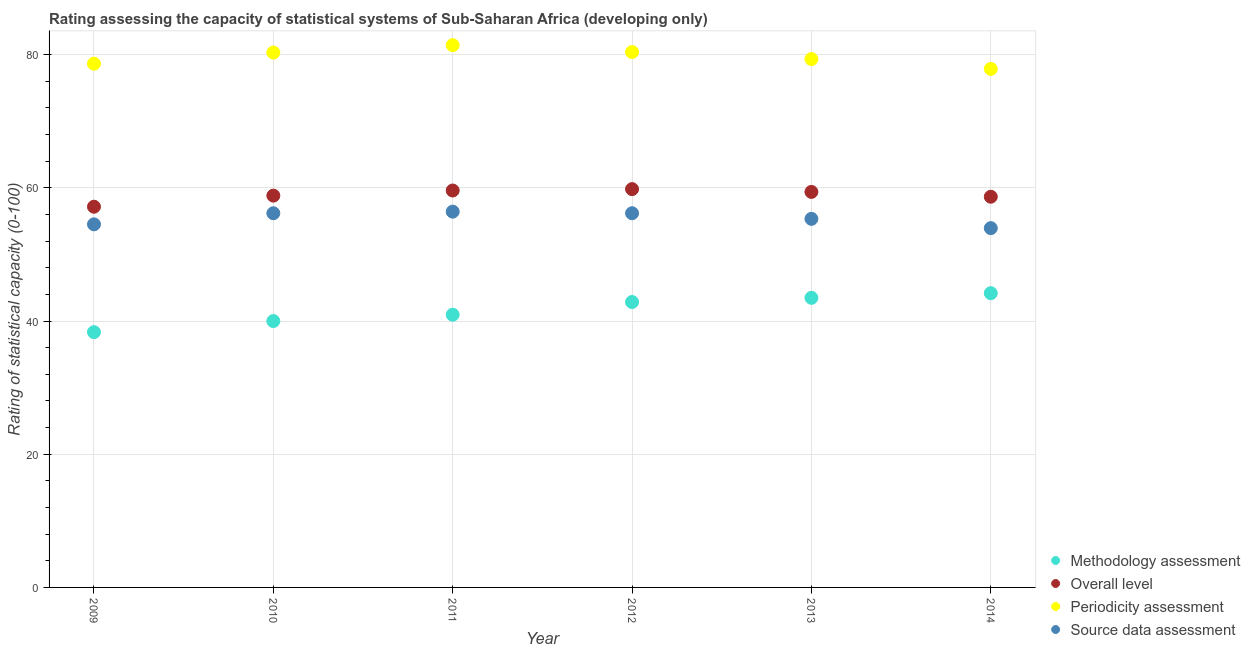How many different coloured dotlines are there?
Offer a terse response. 4. What is the periodicity assessment rating in 2013?
Give a very brief answer. 79.34. Across all years, what is the maximum methodology assessment rating?
Offer a terse response. 44.19. Across all years, what is the minimum periodicity assessment rating?
Provide a succinct answer. 77.87. In which year was the periodicity assessment rating maximum?
Give a very brief answer. 2011. What is the total source data assessment rating in the graph?
Your response must be concise. 332.64. What is the difference between the methodology assessment rating in 2012 and that in 2013?
Keep it short and to the point. -0.63. What is the difference between the source data assessment rating in 2012 and the overall level rating in 2009?
Your response must be concise. -0.98. What is the average methodology assessment rating per year?
Your answer should be very brief. 41.64. In the year 2014, what is the difference between the methodology assessment rating and overall level rating?
Keep it short and to the point. -14.48. What is the ratio of the overall level rating in 2009 to that in 2012?
Provide a succinct answer. 0.96. Is the periodicity assessment rating in 2011 less than that in 2014?
Your answer should be compact. No. Is the difference between the periodicity assessment rating in 2009 and 2010 greater than the difference between the source data assessment rating in 2009 and 2010?
Provide a succinct answer. No. What is the difference between the highest and the second highest periodicity assessment rating?
Offer a very short reply. 1.03. What is the difference between the highest and the lowest overall level rating?
Provide a succinct answer. 2.65. Is the sum of the methodology assessment rating in 2010 and 2014 greater than the maximum source data assessment rating across all years?
Your response must be concise. Yes. Is it the case that in every year, the sum of the periodicity assessment rating and source data assessment rating is greater than the sum of overall level rating and methodology assessment rating?
Provide a succinct answer. Yes. Does the source data assessment rating monotonically increase over the years?
Provide a short and direct response. No. Is the overall level rating strictly greater than the methodology assessment rating over the years?
Keep it short and to the point. Yes. How many dotlines are there?
Provide a succinct answer. 4. How many years are there in the graph?
Offer a very short reply. 6. Are the values on the major ticks of Y-axis written in scientific E-notation?
Keep it short and to the point. No. Does the graph contain grids?
Your answer should be compact. Yes. How many legend labels are there?
Offer a very short reply. 4. How are the legend labels stacked?
Offer a very short reply. Vertical. What is the title of the graph?
Keep it short and to the point. Rating assessing the capacity of statistical systems of Sub-Saharan Africa (developing only). Does "Salary of employees" appear as one of the legend labels in the graph?
Provide a short and direct response. No. What is the label or title of the X-axis?
Keep it short and to the point. Year. What is the label or title of the Y-axis?
Make the answer very short. Rating of statistical capacity (0-100). What is the Rating of statistical capacity (0-100) of Methodology assessment in 2009?
Offer a very short reply. 38.33. What is the Rating of statistical capacity (0-100) in Overall level in 2009?
Provide a succinct answer. 57.17. What is the Rating of statistical capacity (0-100) in Periodicity assessment in 2009?
Keep it short and to the point. 78.65. What is the Rating of statistical capacity (0-100) in Source data assessment in 2009?
Ensure brevity in your answer.  54.52. What is the Rating of statistical capacity (0-100) in Methodology assessment in 2010?
Keep it short and to the point. 40. What is the Rating of statistical capacity (0-100) of Overall level in 2010?
Make the answer very short. 58.84. What is the Rating of statistical capacity (0-100) of Periodicity assessment in 2010?
Ensure brevity in your answer.  80.32. What is the Rating of statistical capacity (0-100) of Source data assessment in 2010?
Offer a terse response. 56.19. What is the Rating of statistical capacity (0-100) of Methodology assessment in 2011?
Provide a short and direct response. 40.95. What is the Rating of statistical capacity (0-100) in Overall level in 2011?
Give a very brief answer. 59.6. What is the Rating of statistical capacity (0-100) of Periodicity assessment in 2011?
Keep it short and to the point. 81.43. What is the Rating of statistical capacity (0-100) of Source data assessment in 2011?
Provide a short and direct response. 56.43. What is the Rating of statistical capacity (0-100) of Methodology assessment in 2012?
Your answer should be very brief. 42.86. What is the Rating of statistical capacity (0-100) of Overall level in 2012?
Give a very brief answer. 59.81. What is the Rating of statistical capacity (0-100) in Periodicity assessment in 2012?
Your answer should be compact. 80.4. What is the Rating of statistical capacity (0-100) of Source data assessment in 2012?
Give a very brief answer. 56.19. What is the Rating of statistical capacity (0-100) in Methodology assessment in 2013?
Provide a short and direct response. 43.49. What is the Rating of statistical capacity (0-100) in Overall level in 2013?
Give a very brief answer. 59.39. What is the Rating of statistical capacity (0-100) of Periodicity assessment in 2013?
Offer a very short reply. 79.34. What is the Rating of statistical capacity (0-100) of Source data assessment in 2013?
Your response must be concise. 55.35. What is the Rating of statistical capacity (0-100) in Methodology assessment in 2014?
Provide a succinct answer. 44.19. What is the Rating of statistical capacity (0-100) in Overall level in 2014?
Your response must be concise. 58.67. What is the Rating of statistical capacity (0-100) in Periodicity assessment in 2014?
Offer a very short reply. 77.87. What is the Rating of statistical capacity (0-100) in Source data assessment in 2014?
Provide a short and direct response. 53.95. Across all years, what is the maximum Rating of statistical capacity (0-100) of Methodology assessment?
Your answer should be very brief. 44.19. Across all years, what is the maximum Rating of statistical capacity (0-100) of Overall level?
Your answer should be very brief. 59.81. Across all years, what is the maximum Rating of statistical capacity (0-100) of Periodicity assessment?
Your answer should be very brief. 81.43. Across all years, what is the maximum Rating of statistical capacity (0-100) of Source data assessment?
Keep it short and to the point. 56.43. Across all years, what is the minimum Rating of statistical capacity (0-100) of Methodology assessment?
Provide a succinct answer. 38.33. Across all years, what is the minimum Rating of statistical capacity (0-100) in Overall level?
Ensure brevity in your answer.  57.17. Across all years, what is the minimum Rating of statistical capacity (0-100) of Periodicity assessment?
Make the answer very short. 77.87. Across all years, what is the minimum Rating of statistical capacity (0-100) in Source data assessment?
Give a very brief answer. 53.95. What is the total Rating of statistical capacity (0-100) in Methodology assessment in the graph?
Give a very brief answer. 249.82. What is the total Rating of statistical capacity (0-100) in Overall level in the graph?
Your answer should be very brief. 353.49. What is the total Rating of statistical capacity (0-100) in Periodicity assessment in the graph?
Your answer should be compact. 478. What is the total Rating of statistical capacity (0-100) of Source data assessment in the graph?
Your response must be concise. 332.64. What is the difference between the Rating of statistical capacity (0-100) of Methodology assessment in 2009 and that in 2010?
Provide a short and direct response. -1.67. What is the difference between the Rating of statistical capacity (0-100) in Overall level in 2009 and that in 2010?
Provide a succinct answer. -1.67. What is the difference between the Rating of statistical capacity (0-100) in Periodicity assessment in 2009 and that in 2010?
Ensure brevity in your answer.  -1.67. What is the difference between the Rating of statistical capacity (0-100) of Source data assessment in 2009 and that in 2010?
Your response must be concise. -1.67. What is the difference between the Rating of statistical capacity (0-100) of Methodology assessment in 2009 and that in 2011?
Your answer should be compact. -2.62. What is the difference between the Rating of statistical capacity (0-100) of Overall level in 2009 and that in 2011?
Keep it short and to the point. -2.43. What is the difference between the Rating of statistical capacity (0-100) in Periodicity assessment in 2009 and that in 2011?
Your response must be concise. -2.78. What is the difference between the Rating of statistical capacity (0-100) of Source data assessment in 2009 and that in 2011?
Give a very brief answer. -1.9. What is the difference between the Rating of statistical capacity (0-100) of Methodology assessment in 2009 and that in 2012?
Your response must be concise. -4.52. What is the difference between the Rating of statistical capacity (0-100) in Overall level in 2009 and that in 2012?
Provide a short and direct response. -2.65. What is the difference between the Rating of statistical capacity (0-100) of Periodicity assessment in 2009 and that in 2012?
Make the answer very short. -1.75. What is the difference between the Rating of statistical capacity (0-100) of Source data assessment in 2009 and that in 2012?
Provide a succinct answer. -1.67. What is the difference between the Rating of statistical capacity (0-100) of Methodology assessment in 2009 and that in 2013?
Your response must be concise. -5.16. What is the difference between the Rating of statistical capacity (0-100) in Overall level in 2009 and that in 2013?
Keep it short and to the point. -2.22. What is the difference between the Rating of statistical capacity (0-100) in Periodicity assessment in 2009 and that in 2013?
Offer a terse response. -0.69. What is the difference between the Rating of statistical capacity (0-100) in Source data assessment in 2009 and that in 2013?
Offer a terse response. -0.82. What is the difference between the Rating of statistical capacity (0-100) in Methodology assessment in 2009 and that in 2014?
Offer a terse response. -5.85. What is the difference between the Rating of statistical capacity (0-100) in Overall level in 2009 and that in 2014?
Provide a succinct answer. -1.5. What is the difference between the Rating of statistical capacity (0-100) in Periodicity assessment in 2009 and that in 2014?
Provide a short and direct response. 0.78. What is the difference between the Rating of statistical capacity (0-100) in Source data assessment in 2009 and that in 2014?
Give a very brief answer. 0.57. What is the difference between the Rating of statistical capacity (0-100) of Methodology assessment in 2010 and that in 2011?
Offer a terse response. -0.95. What is the difference between the Rating of statistical capacity (0-100) of Overall level in 2010 and that in 2011?
Make the answer very short. -0.77. What is the difference between the Rating of statistical capacity (0-100) in Periodicity assessment in 2010 and that in 2011?
Offer a very short reply. -1.11. What is the difference between the Rating of statistical capacity (0-100) in Source data assessment in 2010 and that in 2011?
Make the answer very short. -0.24. What is the difference between the Rating of statistical capacity (0-100) in Methodology assessment in 2010 and that in 2012?
Ensure brevity in your answer.  -2.86. What is the difference between the Rating of statistical capacity (0-100) of Overall level in 2010 and that in 2012?
Your answer should be very brief. -0.98. What is the difference between the Rating of statistical capacity (0-100) of Periodicity assessment in 2010 and that in 2012?
Make the answer very short. -0.08. What is the difference between the Rating of statistical capacity (0-100) of Methodology assessment in 2010 and that in 2013?
Offer a terse response. -3.49. What is the difference between the Rating of statistical capacity (0-100) of Overall level in 2010 and that in 2013?
Offer a terse response. -0.56. What is the difference between the Rating of statistical capacity (0-100) in Periodicity assessment in 2010 and that in 2013?
Offer a very short reply. 0.98. What is the difference between the Rating of statistical capacity (0-100) of Source data assessment in 2010 and that in 2013?
Keep it short and to the point. 0.84. What is the difference between the Rating of statistical capacity (0-100) of Methodology assessment in 2010 and that in 2014?
Give a very brief answer. -4.19. What is the difference between the Rating of statistical capacity (0-100) of Overall level in 2010 and that in 2014?
Offer a very short reply. 0.17. What is the difference between the Rating of statistical capacity (0-100) of Periodicity assessment in 2010 and that in 2014?
Make the answer very short. 2.45. What is the difference between the Rating of statistical capacity (0-100) of Source data assessment in 2010 and that in 2014?
Offer a terse response. 2.24. What is the difference between the Rating of statistical capacity (0-100) in Methodology assessment in 2011 and that in 2012?
Your answer should be very brief. -1.9. What is the difference between the Rating of statistical capacity (0-100) in Overall level in 2011 and that in 2012?
Offer a terse response. -0.21. What is the difference between the Rating of statistical capacity (0-100) of Periodicity assessment in 2011 and that in 2012?
Ensure brevity in your answer.  1.03. What is the difference between the Rating of statistical capacity (0-100) of Source data assessment in 2011 and that in 2012?
Offer a terse response. 0.24. What is the difference between the Rating of statistical capacity (0-100) in Methodology assessment in 2011 and that in 2013?
Your answer should be compact. -2.54. What is the difference between the Rating of statistical capacity (0-100) of Overall level in 2011 and that in 2013?
Offer a terse response. 0.21. What is the difference between the Rating of statistical capacity (0-100) in Periodicity assessment in 2011 and that in 2013?
Offer a very short reply. 2.09. What is the difference between the Rating of statistical capacity (0-100) in Source data assessment in 2011 and that in 2013?
Provide a short and direct response. 1.08. What is the difference between the Rating of statistical capacity (0-100) of Methodology assessment in 2011 and that in 2014?
Offer a terse response. -3.23. What is the difference between the Rating of statistical capacity (0-100) of Overall level in 2011 and that in 2014?
Your response must be concise. 0.93. What is the difference between the Rating of statistical capacity (0-100) of Periodicity assessment in 2011 and that in 2014?
Keep it short and to the point. 3.56. What is the difference between the Rating of statistical capacity (0-100) in Source data assessment in 2011 and that in 2014?
Keep it short and to the point. 2.48. What is the difference between the Rating of statistical capacity (0-100) in Methodology assessment in 2012 and that in 2013?
Your response must be concise. -0.63. What is the difference between the Rating of statistical capacity (0-100) in Overall level in 2012 and that in 2013?
Your answer should be very brief. 0.42. What is the difference between the Rating of statistical capacity (0-100) in Periodicity assessment in 2012 and that in 2013?
Offer a very short reply. 1.06. What is the difference between the Rating of statistical capacity (0-100) of Source data assessment in 2012 and that in 2013?
Offer a terse response. 0.84. What is the difference between the Rating of statistical capacity (0-100) in Methodology assessment in 2012 and that in 2014?
Ensure brevity in your answer.  -1.33. What is the difference between the Rating of statistical capacity (0-100) of Overall level in 2012 and that in 2014?
Offer a very short reply. 1.15. What is the difference between the Rating of statistical capacity (0-100) in Periodicity assessment in 2012 and that in 2014?
Provide a succinct answer. 2.53. What is the difference between the Rating of statistical capacity (0-100) of Source data assessment in 2012 and that in 2014?
Provide a short and direct response. 2.24. What is the difference between the Rating of statistical capacity (0-100) in Methodology assessment in 2013 and that in 2014?
Your response must be concise. -0.7. What is the difference between the Rating of statistical capacity (0-100) of Overall level in 2013 and that in 2014?
Ensure brevity in your answer.  0.72. What is the difference between the Rating of statistical capacity (0-100) of Periodicity assessment in 2013 and that in 2014?
Make the answer very short. 1.47. What is the difference between the Rating of statistical capacity (0-100) of Source data assessment in 2013 and that in 2014?
Offer a very short reply. 1.4. What is the difference between the Rating of statistical capacity (0-100) of Methodology assessment in 2009 and the Rating of statistical capacity (0-100) of Overall level in 2010?
Ensure brevity in your answer.  -20.5. What is the difference between the Rating of statistical capacity (0-100) of Methodology assessment in 2009 and the Rating of statistical capacity (0-100) of Periodicity assessment in 2010?
Offer a very short reply. -41.98. What is the difference between the Rating of statistical capacity (0-100) of Methodology assessment in 2009 and the Rating of statistical capacity (0-100) of Source data assessment in 2010?
Provide a short and direct response. -17.86. What is the difference between the Rating of statistical capacity (0-100) in Overall level in 2009 and the Rating of statistical capacity (0-100) in Periodicity assessment in 2010?
Offer a terse response. -23.15. What is the difference between the Rating of statistical capacity (0-100) in Overall level in 2009 and the Rating of statistical capacity (0-100) in Source data assessment in 2010?
Offer a terse response. 0.98. What is the difference between the Rating of statistical capacity (0-100) of Periodicity assessment in 2009 and the Rating of statistical capacity (0-100) of Source data assessment in 2010?
Your answer should be compact. 22.46. What is the difference between the Rating of statistical capacity (0-100) in Methodology assessment in 2009 and the Rating of statistical capacity (0-100) in Overall level in 2011?
Your response must be concise. -21.27. What is the difference between the Rating of statistical capacity (0-100) of Methodology assessment in 2009 and the Rating of statistical capacity (0-100) of Periodicity assessment in 2011?
Keep it short and to the point. -43.1. What is the difference between the Rating of statistical capacity (0-100) in Methodology assessment in 2009 and the Rating of statistical capacity (0-100) in Source data assessment in 2011?
Ensure brevity in your answer.  -18.1. What is the difference between the Rating of statistical capacity (0-100) in Overall level in 2009 and the Rating of statistical capacity (0-100) in Periodicity assessment in 2011?
Offer a very short reply. -24.26. What is the difference between the Rating of statistical capacity (0-100) of Overall level in 2009 and the Rating of statistical capacity (0-100) of Source data assessment in 2011?
Provide a succinct answer. 0.74. What is the difference between the Rating of statistical capacity (0-100) in Periodicity assessment in 2009 and the Rating of statistical capacity (0-100) in Source data assessment in 2011?
Provide a short and direct response. 22.22. What is the difference between the Rating of statistical capacity (0-100) of Methodology assessment in 2009 and the Rating of statistical capacity (0-100) of Overall level in 2012?
Ensure brevity in your answer.  -21.48. What is the difference between the Rating of statistical capacity (0-100) in Methodology assessment in 2009 and the Rating of statistical capacity (0-100) in Periodicity assessment in 2012?
Your answer should be very brief. -42.06. What is the difference between the Rating of statistical capacity (0-100) of Methodology assessment in 2009 and the Rating of statistical capacity (0-100) of Source data assessment in 2012?
Offer a terse response. -17.86. What is the difference between the Rating of statistical capacity (0-100) in Overall level in 2009 and the Rating of statistical capacity (0-100) in Periodicity assessment in 2012?
Provide a short and direct response. -23.23. What is the difference between the Rating of statistical capacity (0-100) of Overall level in 2009 and the Rating of statistical capacity (0-100) of Source data assessment in 2012?
Offer a terse response. 0.98. What is the difference between the Rating of statistical capacity (0-100) of Periodicity assessment in 2009 and the Rating of statistical capacity (0-100) of Source data assessment in 2012?
Keep it short and to the point. 22.46. What is the difference between the Rating of statistical capacity (0-100) in Methodology assessment in 2009 and the Rating of statistical capacity (0-100) in Overall level in 2013?
Your answer should be very brief. -21.06. What is the difference between the Rating of statistical capacity (0-100) in Methodology assessment in 2009 and the Rating of statistical capacity (0-100) in Periodicity assessment in 2013?
Provide a succinct answer. -41.01. What is the difference between the Rating of statistical capacity (0-100) of Methodology assessment in 2009 and the Rating of statistical capacity (0-100) of Source data assessment in 2013?
Offer a terse response. -17.02. What is the difference between the Rating of statistical capacity (0-100) in Overall level in 2009 and the Rating of statistical capacity (0-100) in Periodicity assessment in 2013?
Your answer should be very brief. -22.17. What is the difference between the Rating of statistical capacity (0-100) in Overall level in 2009 and the Rating of statistical capacity (0-100) in Source data assessment in 2013?
Your answer should be compact. 1.82. What is the difference between the Rating of statistical capacity (0-100) in Periodicity assessment in 2009 and the Rating of statistical capacity (0-100) in Source data assessment in 2013?
Provide a short and direct response. 23.3. What is the difference between the Rating of statistical capacity (0-100) of Methodology assessment in 2009 and the Rating of statistical capacity (0-100) of Overall level in 2014?
Provide a succinct answer. -20.34. What is the difference between the Rating of statistical capacity (0-100) in Methodology assessment in 2009 and the Rating of statistical capacity (0-100) in Periodicity assessment in 2014?
Your response must be concise. -39.53. What is the difference between the Rating of statistical capacity (0-100) of Methodology assessment in 2009 and the Rating of statistical capacity (0-100) of Source data assessment in 2014?
Offer a terse response. -15.62. What is the difference between the Rating of statistical capacity (0-100) in Overall level in 2009 and the Rating of statistical capacity (0-100) in Periodicity assessment in 2014?
Your answer should be very brief. -20.7. What is the difference between the Rating of statistical capacity (0-100) of Overall level in 2009 and the Rating of statistical capacity (0-100) of Source data assessment in 2014?
Make the answer very short. 3.22. What is the difference between the Rating of statistical capacity (0-100) in Periodicity assessment in 2009 and the Rating of statistical capacity (0-100) in Source data assessment in 2014?
Your answer should be very brief. 24.7. What is the difference between the Rating of statistical capacity (0-100) in Methodology assessment in 2010 and the Rating of statistical capacity (0-100) in Overall level in 2011?
Give a very brief answer. -19.6. What is the difference between the Rating of statistical capacity (0-100) of Methodology assessment in 2010 and the Rating of statistical capacity (0-100) of Periodicity assessment in 2011?
Give a very brief answer. -41.43. What is the difference between the Rating of statistical capacity (0-100) in Methodology assessment in 2010 and the Rating of statistical capacity (0-100) in Source data assessment in 2011?
Keep it short and to the point. -16.43. What is the difference between the Rating of statistical capacity (0-100) of Overall level in 2010 and the Rating of statistical capacity (0-100) of Periodicity assessment in 2011?
Offer a terse response. -22.59. What is the difference between the Rating of statistical capacity (0-100) in Overall level in 2010 and the Rating of statistical capacity (0-100) in Source data assessment in 2011?
Your answer should be very brief. 2.41. What is the difference between the Rating of statistical capacity (0-100) of Periodicity assessment in 2010 and the Rating of statistical capacity (0-100) of Source data assessment in 2011?
Provide a succinct answer. 23.89. What is the difference between the Rating of statistical capacity (0-100) in Methodology assessment in 2010 and the Rating of statistical capacity (0-100) in Overall level in 2012?
Provide a succinct answer. -19.81. What is the difference between the Rating of statistical capacity (0-100) in Methodology assessment in 2010 and the Rating of statistical capacity (0-100) in Periodicity assessment in 2012?
Offer a terse response. -40.4. What is the difference between the Rating of statistical capacity (0-100) of Methodology assessment in 2010 and the Rating of statistical capacity (0-100) of Source data assessment in 2012?
Offer a terse response. -16.19. What is the difference between the Rating of statistical capacity (0-100) of Overall level in 2010 and the Rating of statistical capacity (0-100) of Periodicity assessment in 2012?
Provide a succinct answer. -21.56. What is the difference between the Rating of statistical capacity (0-100) in Overall level in 2010 and the Rating of statistical capacity (0-100) in Source data assessment in 2012?
Your answer should be very brief. 2.65. What is the difference between the Rating of statistical capacity (0-100) of Periodicity assessment in 2010 and the Rating of statistical capacity (0-100) of Source data assessment in 2012?
Offer a very short reply. 24.13. What is the difference between the Rating of statistical capacity (0-100) in Methodology assessment in 2010 and the Rating of statistical capacity (0-100) in Overall level in 2013?
Make the answer very short. -19.39. What is the difference between the Rating of statistical capacity (0-100) in Methodology assessment in 2010 and the Rating of statistical capacity (0-100) in Periodicity assessment in 2013?
Your answer should be compact. -39.34. What is the difference between the Rating of statistical capacity (0-100) in Methodology assessment in 2010 and the Rating of statistical capacity (0-100) in Source data assessment in 2013?
Make the answer very short. -15.35. What is the difference between the Rating of statistical capacity (0-100) in Overall level in 2010 and the Rating of statistical capacity (0-100) in Periodicity assessment in 2013?
Provide a succinct answer. -20.51. What is the difference between the Rating of statistical capacity (0-100) of Overall level in 2010 and the Rating of statistical capacity (0-100) of Source data assessment in 2013?
Your answer should be compact. 3.49. What is the difference between the Rating of statistical capacity (0-100) of Periodicity assessment in 2010 and the Rating of statistical capacity (0-100) of Source data assessment in 2013?
Provide a short and direct response. 24.97. What is the difference between the Rating of statistical capacity (0-100) in Methodology assessment in 2010 and the Rating of statistical capacity (0-100) in Overall level in 2014?
Your answer should be very brief. -18.67. What is the difference between the Rating of statistical capacity (0-100) in Methodology assessment in 2010 and the Rating of statistical capacity (0-100) in Periodicity assessment in 2014?
Make the answer very short. -37.87. What is the difference between the Rating of statistical capacity (0-100) in Methodology assessment in 2010 and the Rating of statistical capacity (0-100) in Source data assessment in 2014?
Keep it short and to the point. -13.95. What is the difference between the Rating of statistical capacity (0-100) in Overall level in 2010 and the Rating of statistical capacity (0-100) in Periodicity assessment in 2014?
Offer a very short reply. -19.03. What is the difference between the Rating of statistical capacity (0-100) in Overall level in 2010 and the Rating of statistical capacity (0-100) in Source data assessment in 2014?
Offer a terse response. 4.88. What is the difference between the Rating of statistical capacity (0-100) in Periodicity assessment in 2010 and the Rating of statistical capacity (0-100) in Source data assessment in 2014?
Offer a very short reply. 26.36. What is the difference between the Rating of statistical capacity (0-100) of Methodology assessment in 2011 and the Rating of statistical capacity (0-100) of Overall level in 2012?
Offer a very short reply. -18.86. What is the difference between the Rating of statistical capacity (0-100) in Methodology assessment in 2011 and the Rating of statistical capacity (0-100) in Periodicity assessment in 2012?
Your answer should be compact. -39.44. What is the difference between the Rating of statistical capacity (0-100) in Methodology assessment in 2011 and the Rating of statistical capacity (0-100) in Source data assessment in 2012?
Offer a terse response. -15.24. What is the difference between the Rating of statistical capacity (0-100) in Overall level in 2011 and the Rating of statistical capacity (0-100) in Periodicity assessment in 2012?
Your response must be concise. -20.79. What is the difference between the Rating of statistical capacity (0-100) in Overall level in 2011 and the Rating of statistical capacity (0-100) in Source data assessment in 2012?
Make the answer very short. 3.41. What is the difference between the Rating of statistical capacity (0-100) of Periodicity assessment in 2011 and the Rating of statistical capacity (0-100) of Source data assessment in 2012?
Your answer should be very brief. 25.24. What is the difference between the Rating of statistical capacity (0-100) of Methodology assessment in 2011 and the Rating of statistical capacity (0-100) of Overall level in 2013?
Make the answer very short. -18.44. What is the difference between the Rating of statistical capacity (0-100) in Methodology assessment in 2011 and the Rating of statistical capacity (0-100) in Periodicity assessment in 2013?
Your answer should be very brief. -38.39. What is the difference between the Rating of statistical capacity (0-100) of Methodology assessment in 2011 and the Rating of statistical capacity (0-100) of Source data assessment in 2013?
Keep it short and to the point. -14.4. What is the difference between the Rating of statistical capacity (0-100) of Overall level in 2011 and the Rating of statistical capacity (0-100) of Periodicity assessment in 2013?
Make the answer very short. -19.74. What is the difference between the Rating of statistical capacity (0-100) of Overall level in 2011 and the Rating of statistical capacity (0-100) of Source data assessment in 2013?
Your answer should be compact. 4.25. What is the difference between the Rating of statistical capacity (0-100) in Periodicity assessment in 2011 and the Rating of statistical capacity (0-100) in Source data assessment in 2013?
Give a very brief answer. 26.08. What is the difference between the Rating of statistical capacity (0-100) of Methodology assessment in 2011 and the Rating of statistical capacity (0-100) of Overall level in 2014?
Provide a succinct answer. -17.72. What is the difference between the Rating of statistical capacity (0-100) of Methodology assessment in 2011 and the Rating of statistical capacity (0-100) of Periodicity assessment in 2014?
Your answer should be very brief. -36.92. What is the difference between the Rating of statistical capacity (0-100) of Methodology assessment in 2011 and the Rating of statistical capacity (0-100) of Source data assessment in 2014?
Offer a terse response. -13. What is the difference between the Rating of statistical capacity (0-100) of Overall level in 2011 and the Rating of statistical capacity (0-100) of Periodicity assessment in 2014?
Give a very brief answer. -18.27. What is the difference between the Rating of statistical capacity (0-100) in Overall level in 2011 and the Rating of statistical capacity (0-100) in Source data assessment in 2014?
Your response must be concise. 5.65. What is the difference between the Rating of statistical capacity (0-100) in Periodicity assessment in 2011 and the Rating of statistical capacity (0-100) in Source data assessment in 2014?
Ensure brevity in your answer.  27.48. What is the difference between the Rating of statistical capacity (0-100) in Methodology assessment in 2012 and the Rating of statistical capacity (0-100) in Overall level in 2013?
Provide a succinct answer. -16.54. What is the difference between the Rating of statistical capacity (0-100) of Methodology assessment in 2012 and the Rating of statistical capacity (0-100) of Periodicity assessment in 2013?
Offer a very short reply. -36.48. What is the difference between the Rating of statistical capacity (0-100) in Methodology assessment in 2012 and the Rating of statistical capacity (0-100) in Source data assessment in 2013?
Your response must be concise. -12.49. What is the difference between the Rating of statistical capacity (0-100) in Overall level in 2012 and the Rating of statistical capacity (0-100) in Periodicity assessment in 2013?
Ensure brevity in your answer.  -19.53. What is the difference between the Rating of statistical capacity (0-100) in Overall level in 2012 and the Rating of statistical capacity (0-100) in Source data assessment in 2013?
Keep it short and to the point. 4.47. What is the difference between the Rating of statistical capacity (0-100) of Periodicity assessment in 2012 and the Rating of statistical capacity (0-100) of Source data assessment in 2013?
Give a very brief answer. 25.05. What is the difference between the Rating of statistical capacity (0-100) of Methodology assessment in 2012 and the Rating of statistical capacity (0-100) of Overall level in 2014?
Offer a very short reply. -15.81. What is the difference between the Rating of statistical capacity (0-100) of Methodology assessment in 2012 and the Rating of statistical capacity (0-100) of Periodicity assessment in 2014?
Make the answer very short. -35.01. What is the difference between the Rating of statistical capacity (0-100) in Methodology assessment in 2012 and the Rating of statistical capacity (0-100) in Source data assessment in 2014?
Provide a succinct answer. -11.1. What is the difference between the Rating of statistical capacity (0-100) of Overall level in 2012 and the Rating of statistical capacity (0-100) of Periodicity assessment in 2014?
Provide a succinct answer. -18.05. What is the difference between the Rating of statistical capacity (0-100) of Overall level in 2012 and the Rating of statistical capacity (0-100) of Source data assessment in 2014?
Offer a terse response. 5.86. What is the difference between the Rating of statistical capacity (0-100) in Periodicity assessment in 2012 and the Rating of statistical capacity (0-100) in Source data assessment in 2014?
Your answer should be very brief. 26.44. What is the difference between the Rating of statistical capacity (0-100) in Methodology assessment in 2013 and the Rating of statistical capacity (0-100) in Overall level in 2014?
Make the answer very short. -15.18. What is the difference between the Rating of statistical capacity (0-100) of Methodology assessment in 2013 and the Rating of statistical capacity (0-100) of Periodicity assessment in 2014?
Your answer should be compact. -34.38. What is the difference between the Rating of statistical capacity (0-100) in Methodology assessment in 2013 and the Rating of statistical capacity (0-100) in Source data assessment in 2014?
Offer a terse response. -10.47. What is the difference between the Rating of statistical capacity (0-100) of Overall level in 2013 and the Rating of statistical capacity (0-100) of Periodicity assessment in 2014?
Give a very brief answer. -18.48. What is the difference between the Rating of statistical capacity (0-100) in Overall level in 2013 and the Rating of statistical capacity (0-100) in Source data assessment in 2014?
Provide a succinct answer. 5.44. What is the difference between the Rating of statistical capacity (0-100) in Periodicity assessment in 2013 and the Rating of statistical capacity (0-100) in Source data assessment in 2014?
Provide a succinct answer. 25.39. What is the average Rating of statistical capacity (0-100) of Methodology assessment per year?
Provide a short and direct response. 41.64. What is the average Rating of statistical capacity (0-100) in Overall level per year?
Provide a short and direct response. 58.91. What is the average Rating of statistical capacity (0-100) in Periodicity assessment per year?
Offer a very short reply. 79.67. What is the average Rating of statistical capacity (0-100) in Source data assessment per year?
Give a very brief answer. 55.44. In the year 2009, what is the difference between the Rating of statistical capacity (0-100) in Methodology assessment and Rating of statistical capacity (0-100) in Overall level?
Your answer should be compact. -18.84. In the year 2009, what is the difference between the Rating of statistical capacity (0-100) of Methodology assessment and Rating of statistical capacity (0-100) of Periodicity assessment?
Your response must be concise. -40.32. In the year 2009, what is the difference between the Rating of statistical capacity (0-100) of Methodology assessment and Rating of statistical capacity (0-100) of Source data assessment?
Provide a short and direct response. -16.19. In the year 2009, what is the difference between the Rating of statistical capacity (0-100) in Overall level and Rating of statistical capacity (0-100) in Periodicity assessment?
Your response must be concise. -21.48. In the year 2009, what is the difference between the Rating of statistical capacity (0-100) of Overall level and Rating of statistical capacity (0-100) of Source data assessment?
Offer a very short reply. 2.65. In the year 2009, what is the difference between the Rating of statistical capacity (0-100) in Periodicity assessment and Rating of statistical capacity (0-100) in Source data assessment?
Keep it short and to the point. 24.13. In the year 2010, what is the difference between the Rating of statistical capacity (0-100) of Methodology assessment and Rating of statistical capacity (0-100) of Overall level?
Give a very brief answer. -18.84. In the year 2010, what is the difference between the Rating of statistical capacity (0-100) of Methodology assessment and Rating of statistical capacity (0-100) of Periodicity assessment?
Your answer should be compact. -40.32. In the year 2010, what is the difference between the Rating of statistical capacity (0-100) of Methodology assessment and Rating of statistical capacity (0-100) of Source data assessment?
Provide a succinct answer. -16.19. In the year 2010, what is the difference between the Rating of statistical capacity (0-100) of Overall level and Rating of statistical capacity (0-100) of Periodicity assessment?
Ensure brevity in your answer.  -21.48. In the year 2010, what is the difference between the Rating of statistical capacity (0-100) of Overall level and Rating of statistical capacity (0-100) of Source data assessment?
Provide a succinct answer. 2.65. In the year 2010, what is the difference between the Rating of statistical capacity (0-100) in Periodicity assessment and Rating of statistical capacity (0-100) in Source data assessment?
Give a very brief answer. 24.13. In the year 2011, what is the difference between the Rating of statistical capacity (0-100) of Methodology assessment and Rating of statistical capacity (0-100) of Overall level?
Provide a short and direct response. -18.65. In the year 2011, what is the difference between the Rating of statistical capacity (0-100) in Methodology assessment and Rating of statistical capacity (0-100) in Periodicity assessment?
Your answer should be very brief. -40.48. In the year 2011, what is the difference between the Rating of statistical capacity (0-100) in Methodology assessment and Rating of statistical capacity (0-100) in Source data assessment?
Offer a very short reply. -15.48. In the year 2011, what is the difference between the Rating of statistical capacity (0-100) in Overall level and Rating of statistical capacity (0-100) in Periodicity assessment?
Your response must be concise. -21.83. In the year 2011, what is the difference between the Rating of statistical capacity (0-100) in Overall level and Rating of statistical capacity (0-100) in Source data assessment?
Offer a terse response. 3.17. In the year 2012, what is the difference between the Rating of statistical capacity (0-100) of Methodology assessment and Rating of statistical capacity (0-100) of Overall level?
Your answer should be compact. -16.96. In the year 2012, what is the difference between the Rating of statistical capacity (0-100) in Methodology assessment and Rating of statistical capacity (0-100) in Periodicity assessment?
Offer a very short reply. -37.54. In the year 2012, what is the difference between the Rating of statistical capacity (0-100) of Methodology assessment and Rating of statistical capacity (0-100) of Source data assessment?
Your answer should be compact. -13.33. In the year 2012, what is the difference between the Rating of statistical capacity (0-100) of Overall level and Rating of statistical capacity (0-100) of Periodicity assessment?
Your answer should be very brief. -20.58. In the year 2012, what is the difference between the Rating of statistical capacity (0-100) in Overall level and Rating of statistical capacity (0-100) in Source data assessment?
Offer a very short reply. 3.62. In the year 2012, what is the difference between the Rating of statistical capacity (0-100) of Periodicity assessment and Rating of statistical capacity (0-100) of Source data assessment?
Your answer should be compact. 24.21. In the year 2013, what is the difference between the Rating of statistical capacity (0-100) in Methodology assessment and Rating of statistical capacity (0-100) in Overall level?
Give a very brief answer. -15.9. In the year 2013, what is the difference between the Rating of statistical capacity (0-100) of Methodology assessment and Rating of statistical capacity (0-100) of Periodicity assessment?
Your answer should be compact. -35.85. In the year 2013, what is the difference between the Rating of statistical capacity (0-100) of Methodology assessment and Rating of statistical capacity (0-100) of Source data assessment?
Keep it short and to the point. -11.86. In the year 2013, what is the difference between the Rating of statistical capacity (0-100) in Overall level and Rating of statistical capacity (0-100) in Periodicity assessment?
Offer a terse response. -19.95. In the year 2013, what is the difference between the Rating of statistical capacity (0-100) of Overall level and Rating of statistical capacity (0-100) of Source data assessment?
Give a very brief answer. 4.04. In the year 2013, what is the difference between the Rating of statistical capacity (0-100) of Periodicity assessment and Rating of statistical capacity (0-100) of Source data assessment?
Provide a succinct answer. 23.99. In the year 2014, what is the difference between the Rating of statistical capacity (0-100) in Methodology assessment and Rating of statistical capacity (0-100) in Overall level?
Ensure brevity in your answer.  -14.48. In the year 2014, what is the difference between the Rating of statistical capacity (0-100) in Methodology assessment and Rating of statistical capacity (0-100) in Periodicity assessment?
Make the answer very short. -33.68. In the year 2014, what is the difference between the Rating of statistical capacity (0-100) in Methodology assessment and Rating of statistical capacity (0-100) in Source data assessment?
Give a very brief answer. -9.77. In the year 2014, what is the difference between the Rating of statistical capacity (0-100) of Overall level and Rating of statistical capacity (0-100) of Periodicity assessment?
Your response must be concise. -19.2. In the year 2014, what is the difference between the Rating of statistical capacity (0-100) in Overall level and Rating of statistical capacity (0-100) in Source data assessment?
Keep it short and to the point. 4.72. In the year 2014, what is the difference between the Rating of statistical capacity (0-100) of Periodicity assessment and Rating of statistical capacity (0-100) of Source data assessment?
Keep it short and to the point. 23.91. What is the ratio of the Rating of statistical capacity (0-100) of Methodology assessment in 2009 to that in 2010?
Make the answer very short. 0.96. What is the ratio of the Rating of statistical capacity (0-100) of Overall level in 2009 to that in 2010?
Give a very brief answer. 0.97. What is the ratio of the Rating of statistical capacity (0-100) of Periodicity assessment in 2009 to that in 2010?
Your answer should be very brief. 0.98. What is the ratio of the Rating of statistical capacity (0-100) in Source data assessment in 2009 to that in 2010?
Keep it short and to the point. 0.97. What is the ratio of the Rating of statistical capacity (0-100) of Methodology assessment in 2009 to that in 2011?
Offer a very short reply. 0.94. What is the ratio of the Rating of statistical capacity (0-100) of Overall level in 2009 to that in 2011?
Keep it short and to the point. 0.96. What is the ratio of the Rating of statistical capacity (0-100) in Periodicity assessment in 2009 to that in 2011?
Offer a terse response. 0.97. What is the ratio of the Rating of statistical capacity (0-100) of Source data assessment in 2009 to that in 2011?
Your response must be concise. 0.97. What is the ratio of the Rating of statistical capacity (0-100) in Methodology assessment in 2009 to that in 2012?
Make the answer very short. 0.89. What is the ratio of the Rating of statistical capacity (0-100) of Overall level in 2009 to that in 2012?
Keep it short and to the point. 0.96. What is the ratio of the Rating of statistical capacity (0-100) in Periodicity assessment in 2009 to that in 2012?
Ensure brevity in your answer.  0.98. What is the ratio of the Rating of statistical capacity (0-100) in Source data assessment in 2009 to that in 2012?
Offer a terse response. 0.97. What is the ratio of the Rating of statistical capacity (0-100) in Methodology assessment in 2009 to that in 2013?
Provide a short and direct response. 0.88. What is the ratio of the Rating of statistical capacity (0-100) in Overall level in 2009 to that in 2013?
Offer a terse response. 0.96. What is the ratio of the Rating of statistical capacity (0-100) of Source data assessment in 2009 to that in 2013?
Keep it short and to the point. 0.99. What is the ratio of the Rating of statistical capacity (0-100) of Methodology assessment in 2009 to that in 2014?
Keep it short and to the point. 0.87. What is the ratio of the Rating of statistical capacity (0-100) of Overall level in 2009 to that in 2014?
Give a very brief answer. 0.97. What is the ratio of the Rating of statistical capacity (0-100) of Periodicity assessment in 2009 to that in 2014?
Your answer should be compact. 1.01. What is the ratio of the Rating of statistical capacity (0-100) in Source data assessment in 2009 to that in 2014?
Your response must be concise. 1.01. What is the ratio of the Rating of statistical capacity (0-100) in Methodology assessment in 2010 to that in 2011?
Provide a succinct answer. 0.98. What is the ratio of the Rating of statistical capacity (0-100) of Overall level in 2010 to that in 2011?
Your answer should be compact. 0.99. What is the ratio of the Rating of statistical capacity (0-100) of Periodicity assessment in 2010 to that in 2011?
Offer a terse response. 0.99. What is the ratio of the Rating of statistical capacity (0-100) of Source data assessment in 2010 to that in 2011?
Your answer should be very brief. 1. What is the ratio of the Rating of statistical capacity (0-100) in Methodology assessment in 2010 to that in 2012?
Make the answer very short. 0.93. What is the ratio of the Rating of statistical capacity (0-100) in Overall level in 2010 to that in 2012?
Your response must be concise. 0.98. What is the ratio of the Rating of statistical capacity (0-100) of Periodicity assessment in 2010 to that in 2012?
Offer a very short reply. 1. What is the ratio of the Rating of statistical capacity (0-100) of Methodology assessment in 2010 to that in 2013?
Your answer should be very brief. 0.92. What is the ratio of the Rating of statistical capacity (0-100) in Overall level in 2010 to that in 2013?
Make the answer very short. 0.99. What is the ratio of the Rating of statistical capacity (0-100) of Periodicity assessment in 2010 to that in 2013?
Keep it short and to the point. 1.01. What is the ratio of the Rating of statistical capacity (0-100) in Source data assessment in 2010 to that in 2013?
Offer a terse response. 1.02. What is the ratio of the Rating of statistical capacity (0-100) in Methodology assessment in 2010 to that in 2014?
Give a very brief answer. 0.91. What is the ratio of the Rating of statistical capacity (0-100) in Periodicity assessment in 2010 to that in 2014?
Offer a terse response. 1.03. What is the ratio of the Rating of statistical capacity (0-100) in Source data assessment in 2010 to that in 2014?
Your response must be concise. 1.04. What is the ratio of the Rating of statistical capacity (0-100) of Methodology assessment in 2011 to that in 2012?
Your answer should be very brief. 0.96. What is the ratio of the Rating of statistical capacity (0-100) of Periodicity assessment in 2011 to that in 2012?
Offer a terse response. 1.01. What is the ratio of the Rating of statistical capacity (0-100) of Methodology assessment in 2011 to that in 2013?
Your answer should be very brief. 0.94. What is the ratio of the Rating of statistical capacity (0-100) of Overall level in 2011 to that in 2013?
Ensure brevity in your answer.  1. What is the ratio of the Rating of statistical capacity (0-100) in Periodicity assessment in 2011 to that in 2013?
Your answer should be very brief. 1.03. What is the ratio of the Rating of statistical capacity (0-100) in Source data assessment in 2011 to that in 2013?
Your answer should be very brief. 1.02. What is the ratio of the Rating of statistical capacity (0-100) of Methodology assessment in 2011 to that in 2014?
Provide a short and direct response. 0.93. What is the ratio of the Rating of statistical capacity (0-100) in Overall level in 2011 to that in 2014?
Your answer should be compact. 1.02. What is the ratio of the Rating of statistical capacity (0-100) of Periodicity assessment in 2011 to that in 2014?
Provide a short and direct response. 1.05. What is the ratio of the Rating of statistical capacity (0-100) in Source data assessment in 2011 to that in 2014?
Give a very brief answer. 1.05. What is the ratio of the Rating of statistical capacity (0-100) of Methodology assessment in 2012 to that in 2013?
Your response must be concise. 0.99. What is the ratio of the Rating of statistical capacity (0-100) in Overall level in 2012 to that in 2013?
Your answer should be very brief. 1.01. What is the ratio of the Rating of statistical capacity (0-100) of Periodicity assessment in 2012 to that in 2013?
Offer a very short reply. 1.01. What is the ratio of the Rating of statistical capacity (0-100) in Source data assessment in 2012 to that in 2013?
Offer a very short reply. 1.02. What is the ratio of the Rating of statistical capacity (0-100) in Methodology assessment in 2012 to that in 2014?
Provide a short and direct response. 0.97. What is the ratio of the Rating of statistical capacity (0-100) of Overall level in 2012 to that in 2014?
Make the answer very short. 1.02. What is the ratio of the Rating of statistical capacity (0-100) of Periodicity assessment in 2012 to that in 2014?
Offer a terse response. 1.03. What is the ratio of the Rating of statistical capacity (0-100) of Source data assessment in 2012 to that in 2014?
Give a very brief answer. 1.04. What is the ratio of the Rating of statistical capacity (0-100) of Methodology assessment in 2013 to that in 2014?
Your answer should be very brief. 0.98. What is the ratio of the Rating of statistical capacity (0-100) in Overall level in 2013 to that in 2014?
Give a very brief answer. 1.01. What is the ratio of the Rating of statistical capacity (0-100) of Periodicity assessment in 2013 to that in 2014?
Ensure brevity in your answer.  1.02. What is the ratio of the Rating of statistical capacity (0-100) of Source data assessment in 2013 to that in 2014?
Ensure brevity in your answer.  1.03. What is the difference between the highest and the second highest Rating of statistical capacity (0-100) in Methodology assessment?
Provide a short and direct response. 0.7. What is the difference between the highest and the second highest Rating of statistical capacity (0-100) in Overall level?
Your response must be concise. 0.21. What is the difference between the highest and the second highest Rating of statistical capacity (0-100) of Periodicity assessment?
Ensure brevity in your answer.  1.03. What is the difference between the highest and the second highest Rating of statistical capacity (0-100) in Source data assessment?
Your answer should be very brief. 0.24. What is the difference between the highest and the lowest Rating of statistical capacity (0-100) in Methodology assessment?
Provide a short and direct response. 5.85. What is the difference between the highest and the lowest Rating of statistical capacity (0-100) of Overall level?
Your response must be concise. 2.65. What is the difference between the highest and the lowest Rating of statistical capacity (0-100) of Periodicity assessment?
Ensure brevity in your answer.  3.56. What is the difference between the highest and the lowest Rating of statistical capacity (0-100) of Source data assessment?
Your answer should be compact. 2.48. 